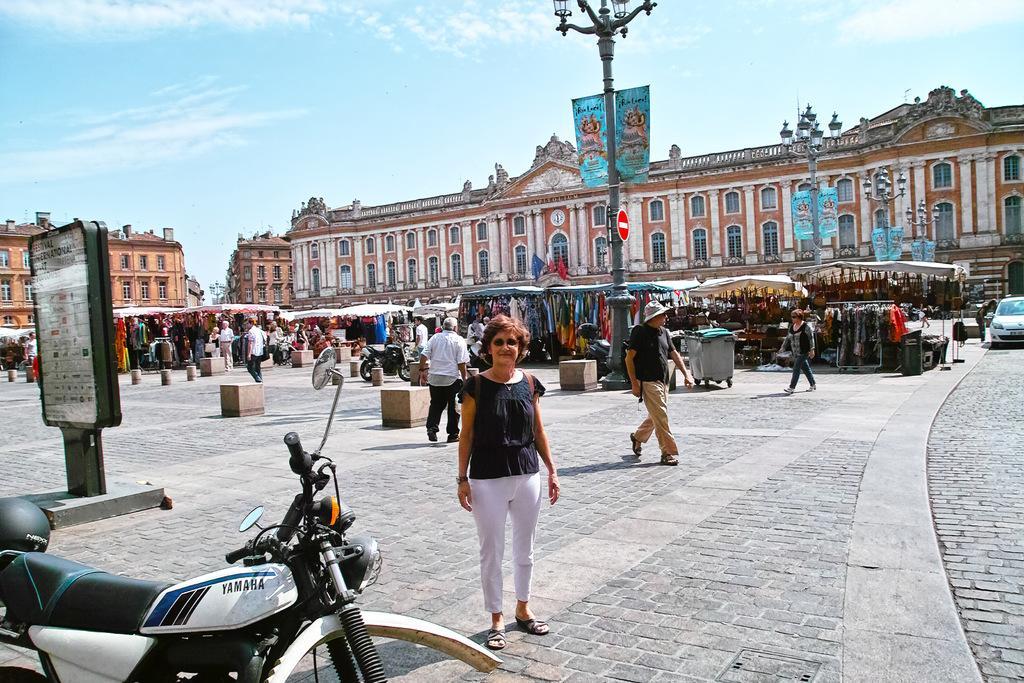Please provide a concise description of this image. In this image we can see there are a few people standing and few people standing on the ground and there are pillars, vehicles, dustbin and board on the ground. And we can see there are stalls. At the back there are buildings, street lights, banner and the sky. 